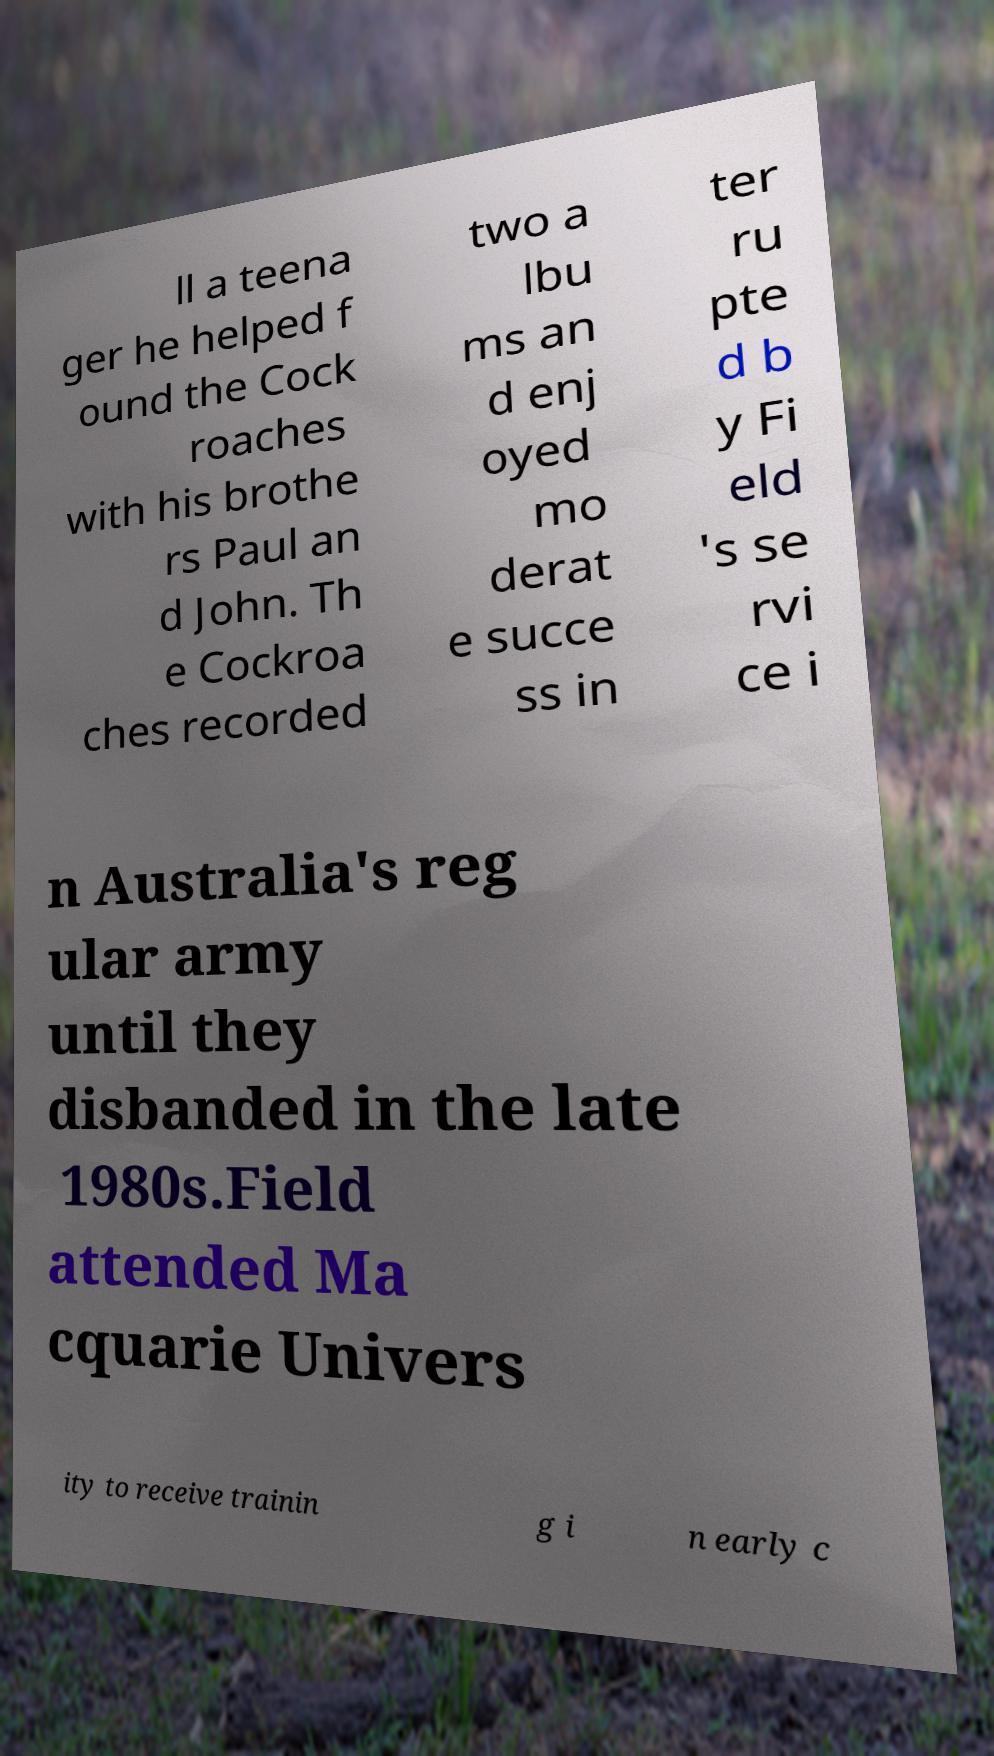For documentation purposes, I need the text within this image transcribed. Could you provide that? ll a teena ger he helped f ound the Cock roaches with his brothe rs Paul an d John. Th e Cockroa ches recorded two a lbu ms an d enj oyed mo derat e succe ss in ter ru pte d b y Fi eld 's se rvi ce i n Australia's reg ular army until they disbanded in the late 1980s.Field attended Ma cquarie Univers ity to receive trainin g i n early c 